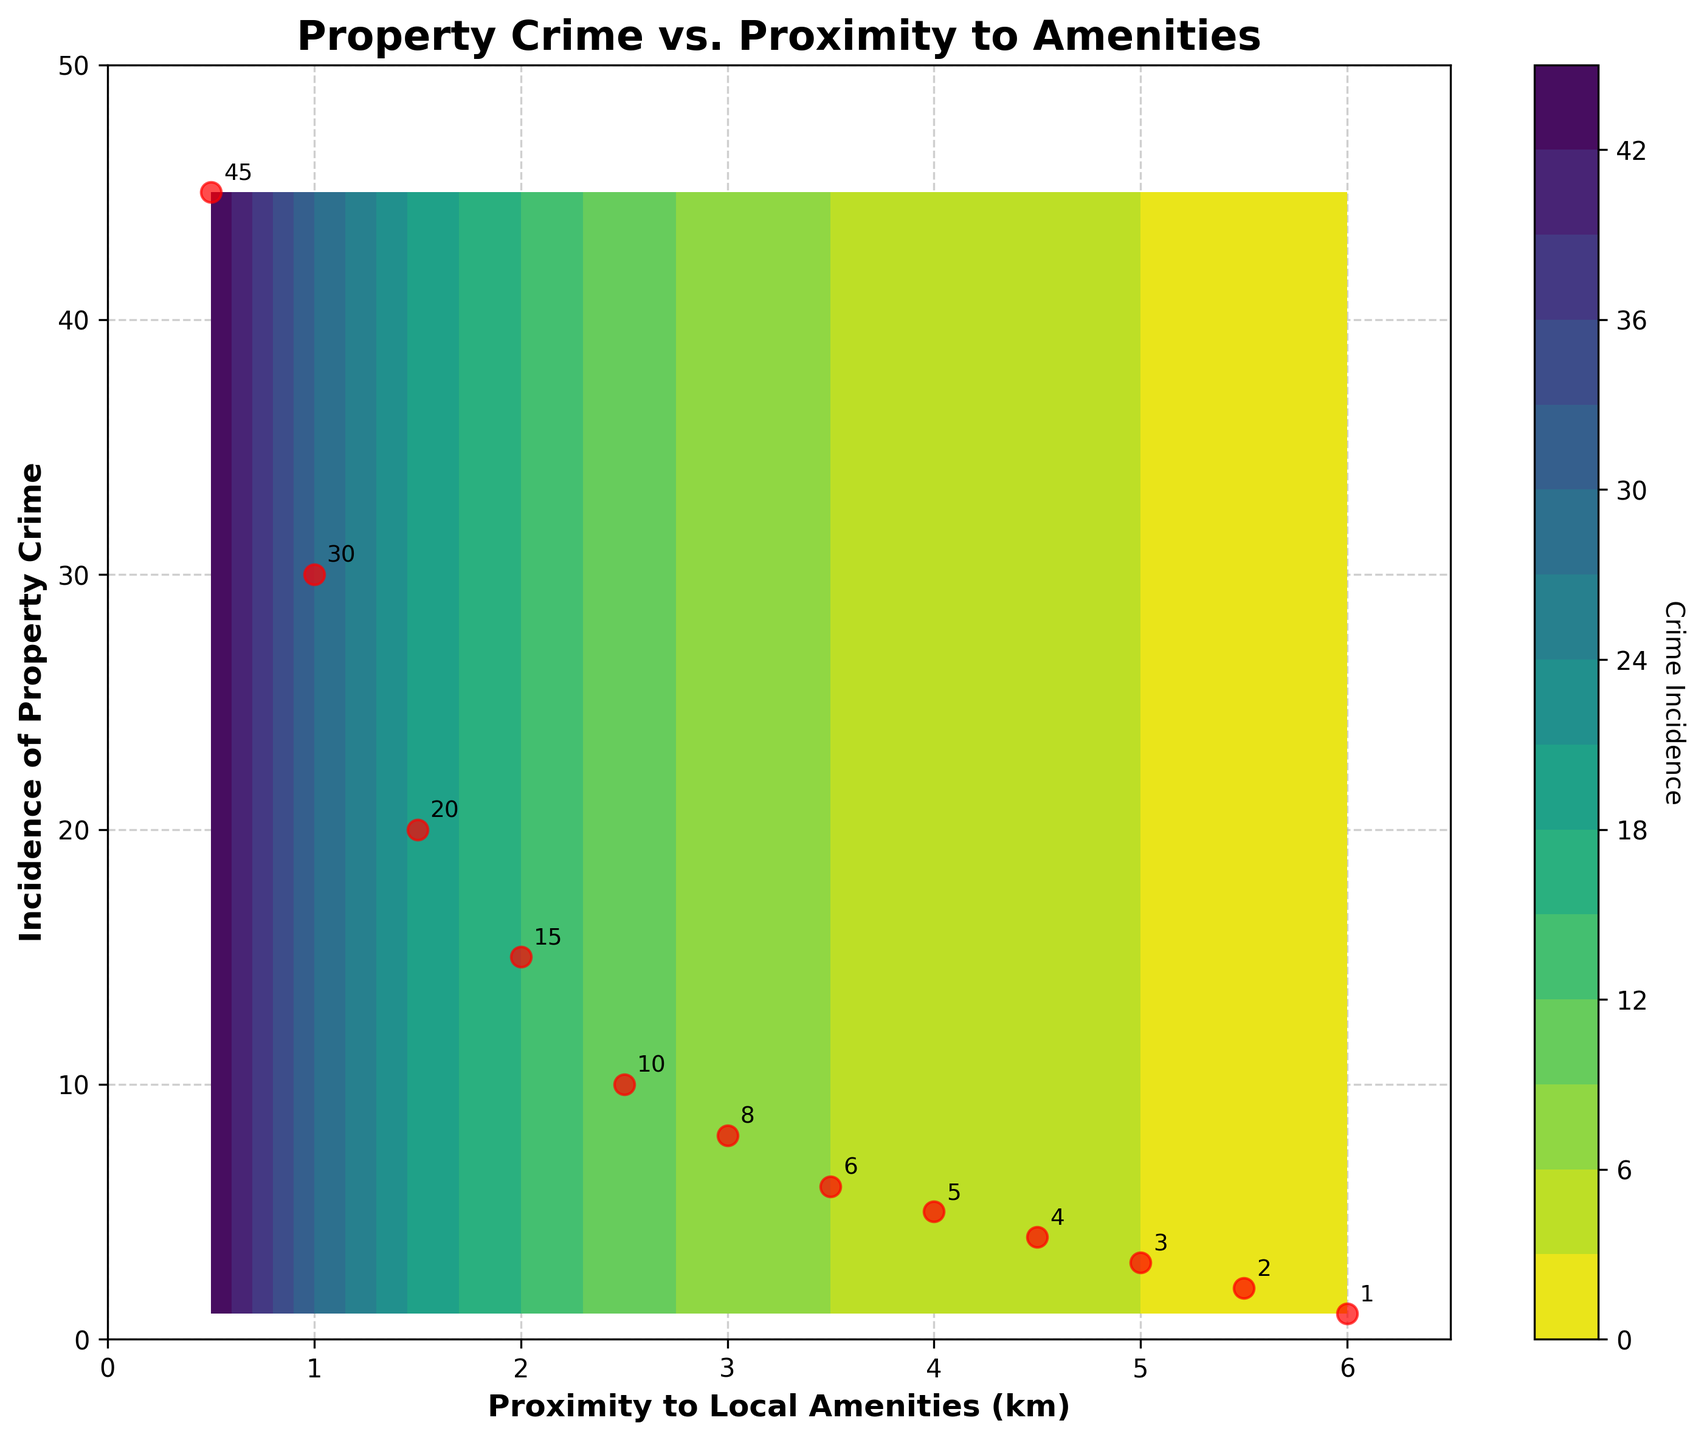What is the title of the plot? The title of the plot is displayed at the top of the figure and reads "Property Crime vs. Proximity to Amenities."
Answer: Property Crime vs. Proximity to Amenities How many data points are plotted as red circles? The red circles represent individual data points, and counting them on the plot shows there are 12 red circles.
Answer: 12 What does the x-axis label represent? The label on the x-axis indicates that it represents "Proximity to Local Amenities" measured in kilometers.
Answer: Proximity to Local Amenities (km) What value of proximity to amenities corresponds to the highest incidence of property crime? By observing the plot, the highest incidence of property crime is at 0.5 kilometers proximity to amenities, with a value of 45.
Answer: 0.5 km Is there a general trend observed between proximity to amenities and incidence of property crime? There is a general decreasing trend where the incidence of property crime decreases as the proximity to local amenities increases. This can be seen through the overall sloping downwards pattern of the data points and the contour levels.
Answer: Decreasing trend What is the incidence of property crime at 3.5 kilometers proximity to amenities? By locating the point on the graph where proximity is 3.5 km, the corresponding incidence of property crime can be identified, which is 6.
Answer: 6 How does the incidence of property crime at 1.5 km compare to that at 5.5 km? Observing the plot, at 1.5 km proximity to amenities, the incidence of property crime is 20, whereas at 5.5 km, it is significantly lower at 2.
Answer: Higher at 1.5 km What is the range of incidence of property crime values shown on the y-axis? The y-axis shows values ranging from a minimum of 1 to a maximum of 45 for incidence of property crime.
Answer: 1 to 45 What is the contour plot level color for an incidence of property crime of 10? The contour plot level color for an incidence of 10 can be identified from the colorbar and observing the corresponding color level, which appears to be a specific shade of green within the viridis color map.
Answer: Shade of green For what range of proximity to amenities do the property crime values fall below 10? From the plot, property crime values fall below 10 when the proximity to local amenities is greater than 2.5 km.
Answer: Greater than 2.5 km 